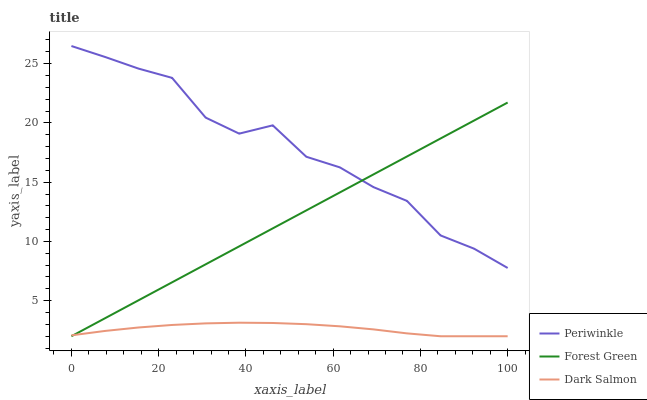Does Dark Salmon have the minimum area under the curve?
Answer yes or no. Yes. Does Periwinkle have the maximum area under the curve?
Answer yes or no. Yes. Does Periwinkle have the minimum area under the curve?
Answer yes or no. No. Does Dark Salmon have the maximum area under the curve?
Answer yes or no. No. Is Forest Green the smoothest?
Answer yes or no. Yes. Is Periwinkle the roughest?
Answer yes or no. Yes. Is Dark Salmon the smoothest?
Answer yes or no. No. Is Dark Salmon the roughest?
Answer yes or no. No. Does Forest Green have the lowest value?
Answer yes or no. Yes. Does Periwinkle have the lowest value?
Answer yes or no. No. Does Periwinkle have the highest value?
Answer yes or no. Yes. Does Dark Salmon have the highest value?
Answer yes or no. No. Is Dark Salmon less than Periwinkle?
Answer yes or no. Yes. Is Periwinkle greater than Dark Salmon?
Answer yes or no. Yes. Does Dark Salmon intersect Forest Green?
Answer yes or no. Yes. Is Dark Salmon less than Forest Green?
Answer yes or no. No. Is Dark Salmon greater than Forest Green?
Answer yes or no. No. Does Dark Salmon intersect Periwinkle?
Answer yes or no. No. 